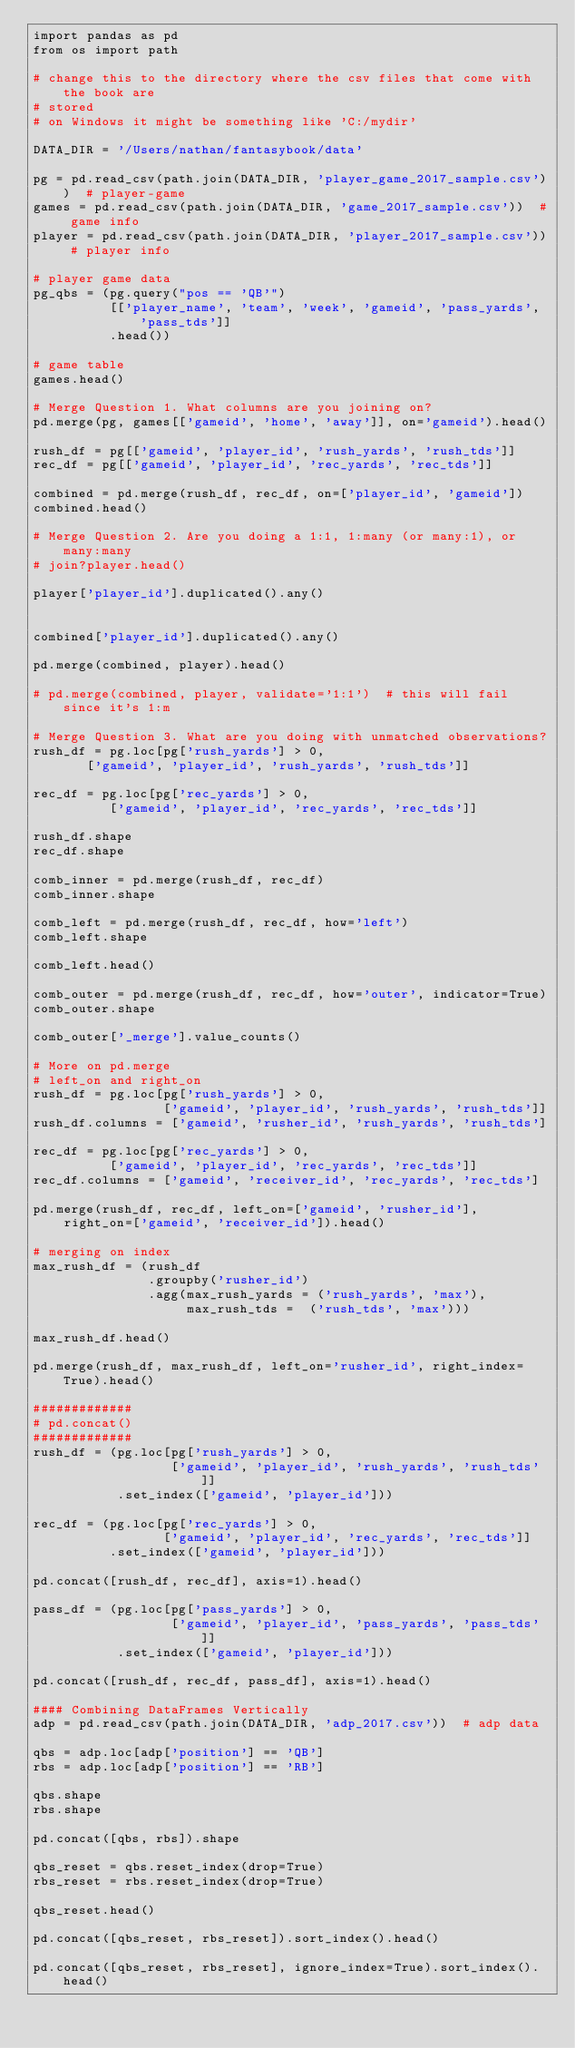<code> <loc_0><loc_0><loc_500><loc_500><_Python_>import pandas as pd
from os import path

# change this to the directory where the csv files that come with the book are
# stored
# on Windows it might be something like 'C:/mydir'

DATA_DIR = '/Users/nathan/fantasybook/data'

pg = pd.read_csv(path.join(DATA_DIR, 'player_game_2017_sample.csv'))  # player-game
games = pd.read_csv(path.join(DATA_DIR, 'game_2017_sample.csv'))  # game info
player = pd.read_csv(path.join(DATA_DIR, 'player_2017_sample.csv')) # player info

# player game data
pg_qbs = (pg.query("pos == 'QB'")
          [['player_name', 'team', 'week', 'gameid', 'pass_yards', 'pass_tds']]
          .head())

# game table
games.head()

# Merge Question 1. What columns are you joining on?
pd.merge(pg, games[['gameid', 'home', 'away']], on='gameid').head()

rush_df = pg[['gameid', 'player_id', 'rush_yards', 'rush_tds']]
rec_df = pg[['gameid', 'player_id', 'rec_yards', 'rec_tds']]

combined = pd.merge(rush_df, rec_df, on=['player_id', 'gameid'])
combined.head()

# Merge Question 2. Are you doing a 1:1, 1:many (or many:1), or many:many
# join?player.head()

player['player_id'].duplicated().any()


combined['player_id'].duplicated().any()

pd.merge(combined, player).head()

# pd.merge(combined, player, validate='1:1')  # this will fail since it's 1:m

# Merge Question 3. What are you doing with unmatched observations?
rush_df = pg.loc[pg['rush_yards'] > 0,
       ['gameid', 'player_id', 'rush_yards', 'rush_tds']]

rec_df = pg.loc[pg['rec_yards'] > 0,
          ['gameid', 'player_id', 'rec_yards', 'rec_tds']]

rush_df.shape
rec_df.shape

comb_inner = pd.merge(rush_df, rec_df)
comb_inner.shape

comb_left = pd.merge(rush_df, rec_df, how='left')
comb_left.shape

comb_left.head()

comb_outer = pd.merge(rush_df, rec_df, how='outer', indicator=True)
comb_outer.shape

comb_outer['_merge'].value_counts()

# More on pd.merge
# left_on and right_on
rush_df = pg.loc[pg['rush_yards'] > 0,
                 ['gameid', 'player_id', 'rush_yards', 'rush_tds']]
rush_df.columns = ['gameid', 'rusher_id', 'rush_yards', 'rush_tds']

rec_df = pg.loc[pg['rec_yards'] > 0,
          ['gameid', 'player_id', 'rec_yards', 'rec_tds']]
rec_df.columns = ['gameid', 'receiver_id', 'rec_yards', 'rec_tds']

pd.merge(rush_df, rec_df, left_on=['gameid', 'rusher_id'],
    right_on=['gameid', 'receiver_id']).head()

# merging on index
max_rush_df = (rush_df
               .groupby('rusher_id')
               .agg(max_rush_yards = ('rush_yards', 'max'),
                    max_rush_tds =  ('rush_tds', 'max')))

max_rush_df.head()

pd.merge(rush_df, max_rush_df, left_on='rusher_id', right_index=True).head()

#############
# pd.concat()
#############
rush_df = (pg.loc[pg['rush_yards'] > 0,
                  ['gameid', 'player_id', 'rush_yards', 'rush_tds']]
           .set_index(['gameid', 'player_id']))

rec_df = (pg.loc[pg['rec_yards'] > 0,
                 ['gameid', 'player_id', 'rec_yards', 'rec_tds']]
          .set_index(['gameid', 'player_id']))

pd.concat([rush_df, rec_df], axis=1).head()

pass_df = (pg.loc[pg['pass_yards'] > 0,
                  ['gameid', 'player_id', 'pass_yards', 'pass_tds']]
           .set_index(['gameid', 'player_id']))

pd.concat([rush_df, rec_df, pass_df], axis=1).head()

#### Combining DataFrames Vertically
adp = pd.read_csv(path.join(DATA_DIR, 'adp_2017.csv'))  # adp data

qbs = adp.loc[adp['position'] == 'QB']
rbs = adp.loc[adp['position'] == 'RB']

qbs.shape
rbs.shape

pd.concat([qbs, rbs]).shape

qbs_reset = qbs.reset_index(drop=True)
rbs_reset = rbs.reset_index(drop=True)

qbs_reset.head()

pd.concat([qbs_reset, rbs_reset]).sort_index().head()

pd.concat([qbs_reset, rbs_reset], ignore_index=True).sort_index().head()
</code> 